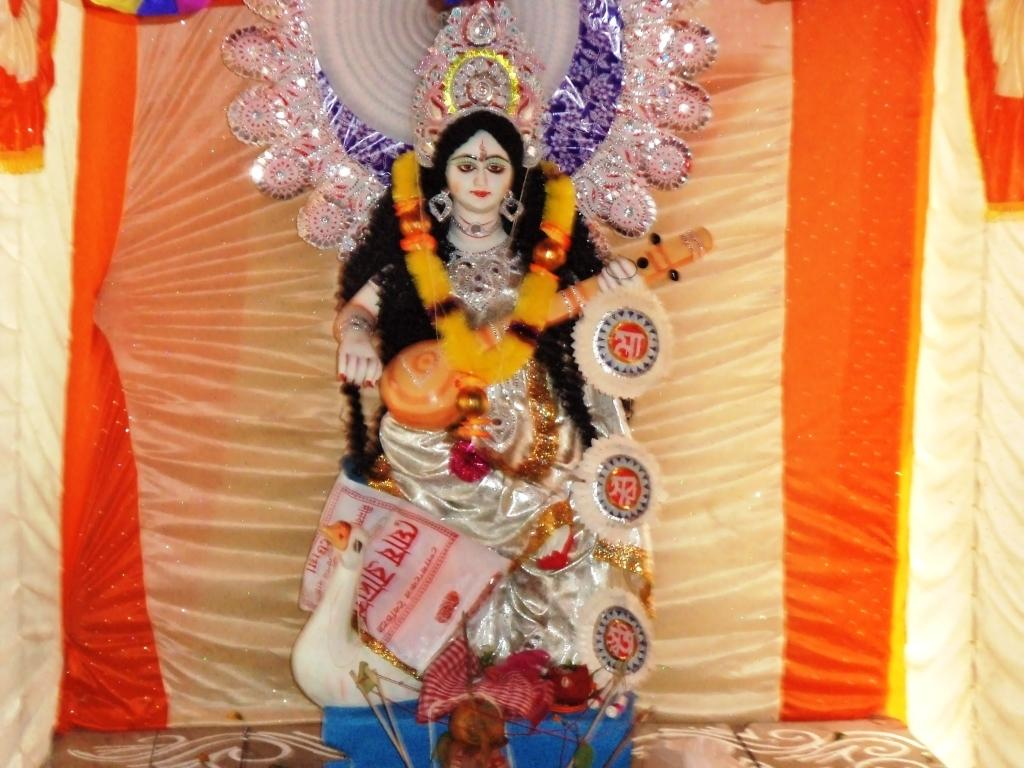What is the main subject of the image? There is a god's idol in the image. What type of clothing can be seen in the image? There are multicolored clothes in the image. What can be seen in the background of the image? There are curtains in the background of the image. What colors are the curtains? The curtains are in cream and orange colors. What type of zinc object is present in the image? There is no zinc object present in the image. What holiday is being celebrated in the image? The image does not depict a specific holiday being celebrated. 